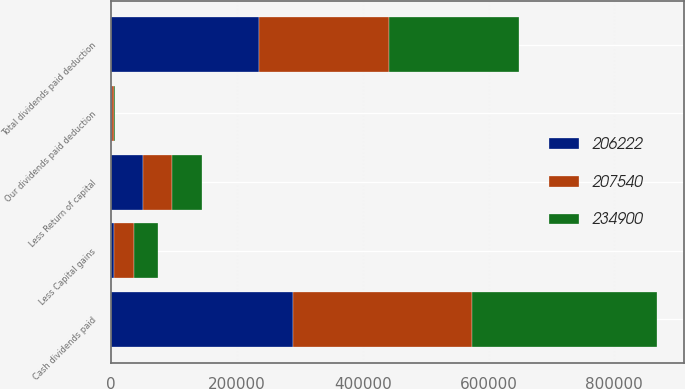Convert chart. <chart><loc_0><loc_0><loc_500><loc_500><stacked_bar_chart><ecel><fcel>Our dividends paid deduction<fcel>Cash dividends paid<fcel>Less Capital gains<fcel>Less Return of capital<fcel>Total dividends paid deduction<nl><fcel>234900<fcel>2004<fcel>292889<fcel>38655<fcel>46694<fcel>207540<nl><fcel>207540<fcel>2003<fcel>284868<fcel>32009<fcel>46637<fcel>206222<nl><fcel>206222<fcel>2002<fcel>289528<fcel>4203<fcel>50425<fcel>234900<nl></chart> 